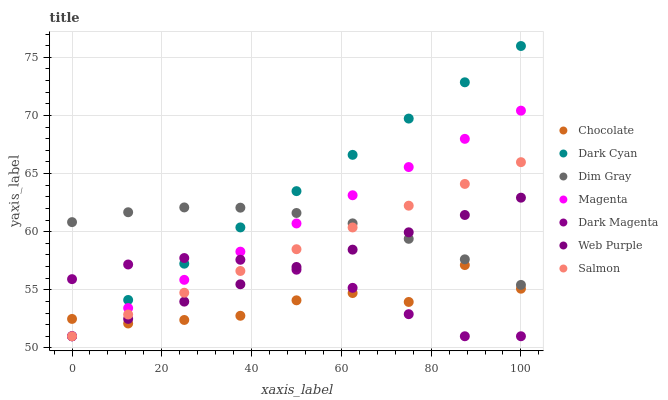Does Chocolate have the minimum area under the curve?
Answer yes or no. Yes. Does Dark Cyan have the maximum area under the curve?
Answer yes or no. Yes. Does Dark Magenta have the minimum area under the curve?
Answer yes or no. No. Does Dark Magenta have the maximum area under the curve?
Answer yes or no. No. Is Magenta the smoothest?
Answer yes or no. Yes. Is Chocolate the roughest?
Answer yes or no. Yes. Is Dark Magenta the smoothest?
Answer yes or no. No. Is Dark Magenta the roughest?
Answer yes or no. No. Does Dark Magenta have the lowest value?
Answer yes or no. Yes. Does Chocolate have the lowest value?
Answer yes or no. No. Does Dark Cyan have the highest value?
Answer yes or no. Yes. Does Dark Magenta have the highest value?
Answer yes or no. No. Is Dark Magenta less than Dim Gray?
Answer yes or no. Yes. Is Dim Gray greater than Chocolate?
Answer yes or no. Yes. Does Dark Cyan intersect Dim Gray?
Answer yes or no. Yes. Is Dark Cyan less than Dim Gray?
Answer yes or no. No. Is Dark Cyan greater than Dim Gray?
Answer yes or no. No. Does Dark Magenta intersect Dim Gray?
Answer yes or no. No. 